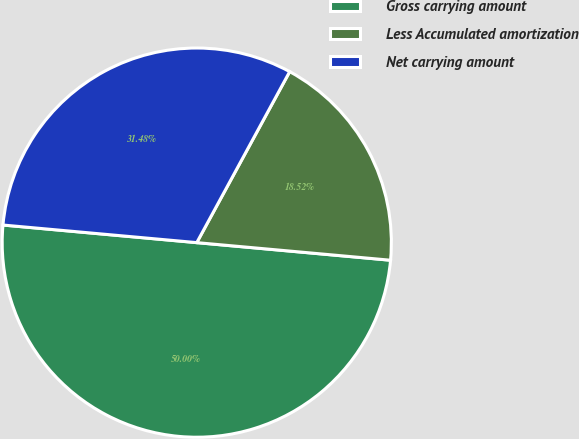<chart> <loc_0><loc_0><loc_500><loc_500><pie_chart><fcel>Gross carrying amount<fcel>Less Accumulated amortization<fcel>Net carrying amount<nl><fcel>50.0%<fcel>18.52%<fcel>31.48%<nl></chart> 